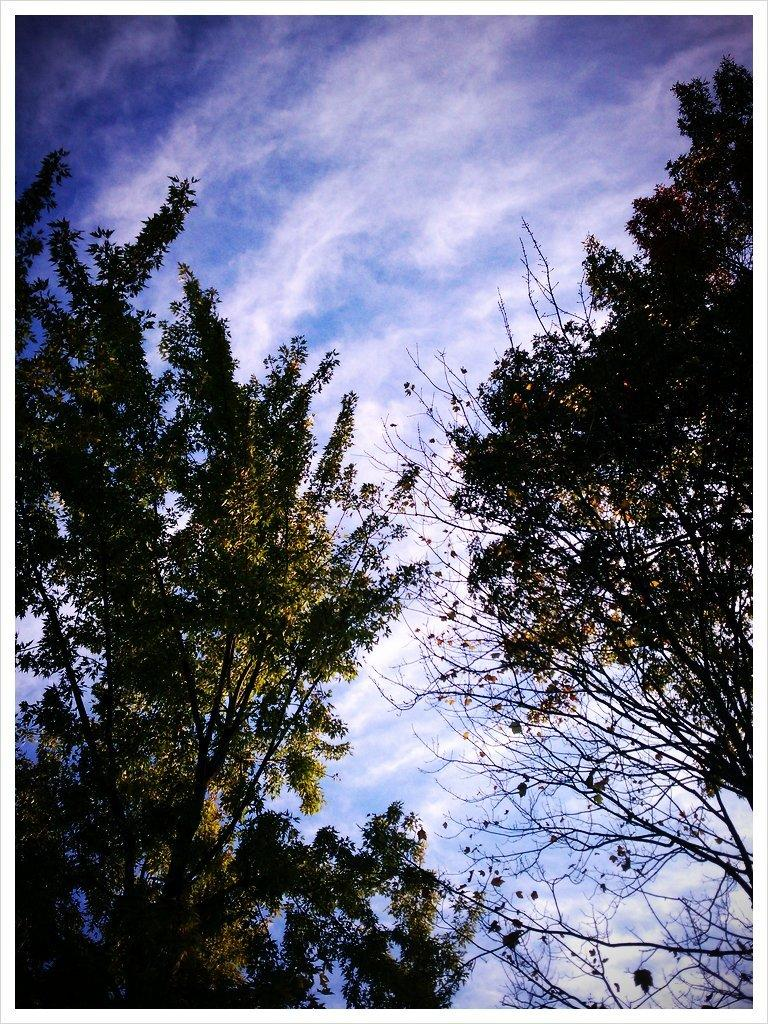What type of vegetation can be seen in the image? There are trees in the image. What part of the natural environment is visible in the image? The sky is visible in the background of the image. What religion is the deer practicing in the image? There is no deer present in the image, so it is not possible to determine what religion it might be practicing. 